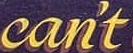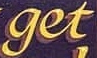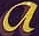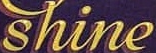Transcribe the words shown in these images in order, separated by a semicolon. can't; get; a; shine 